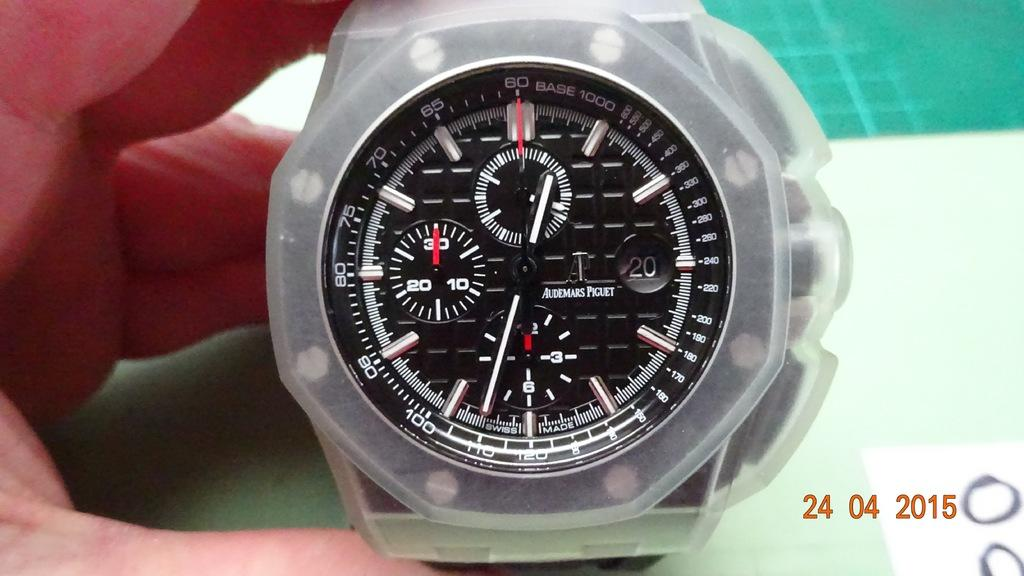<image>
Give a short and clear explanation of the subsequent image. A watch with a number of dials, one of which is pointing to 30. 